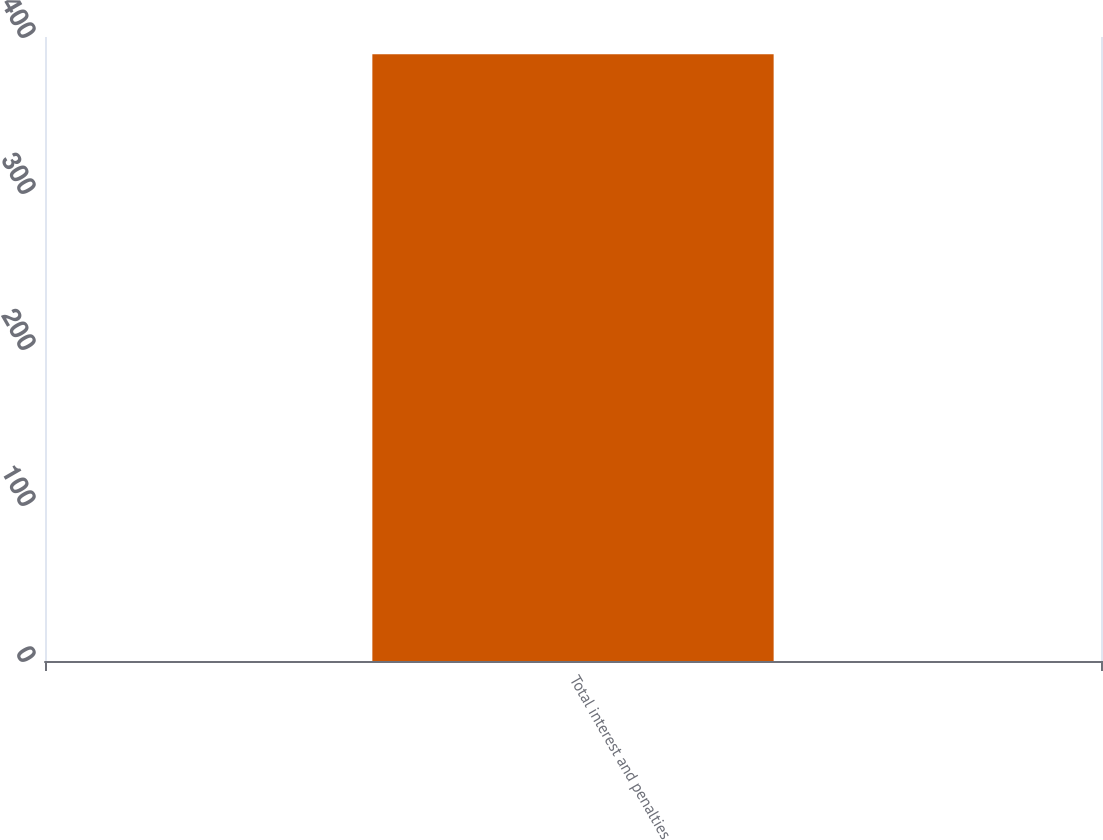<chart> <loc_0><loc_0><loc_500><loc_500><bar_chart><fcel>Total interest and penalties<nl><fcel>389<nl></chart> 